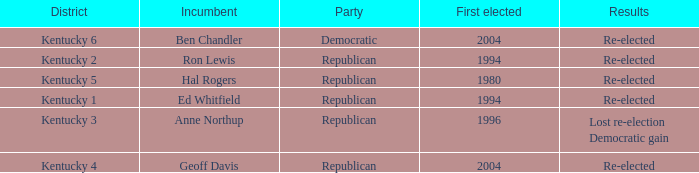In what year was the republican incumbent from Kentucky 2 district first elected? 1994.0. 